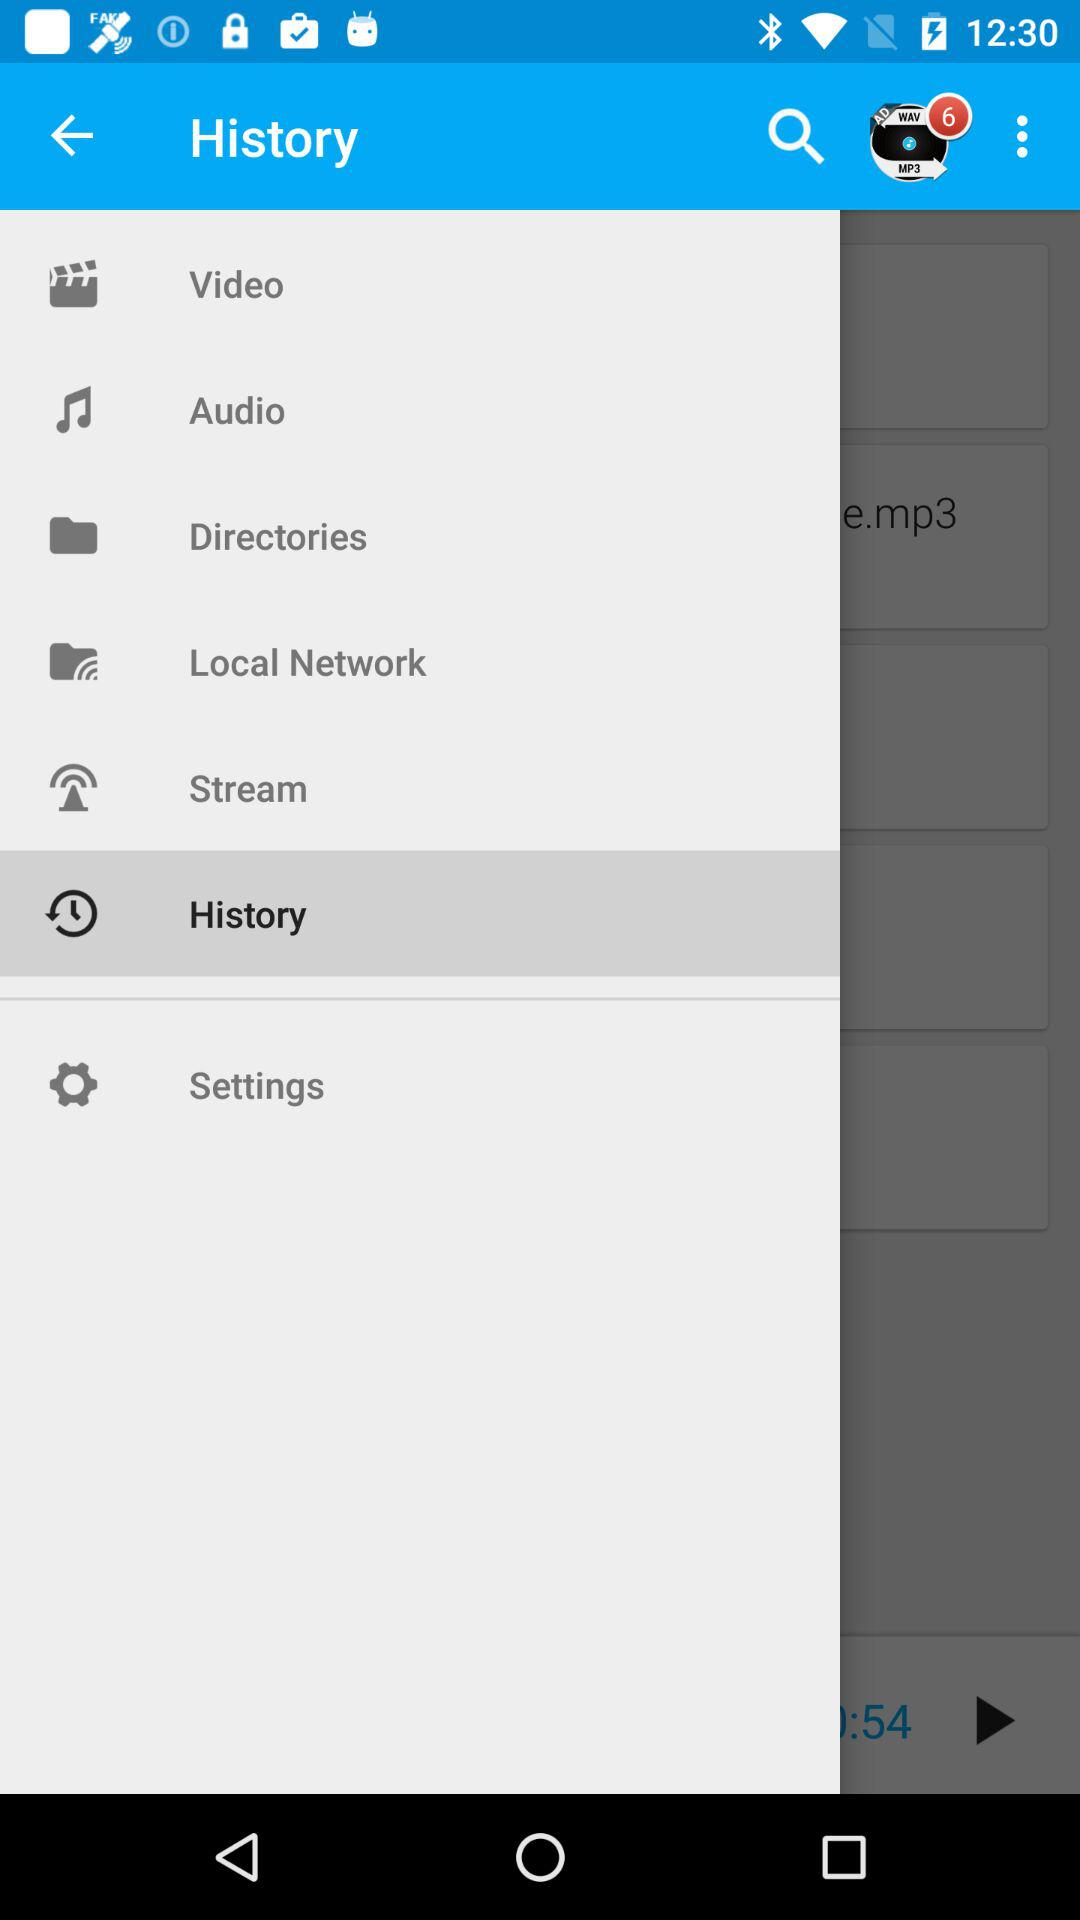Which is the selected option? The selected option is "History". 